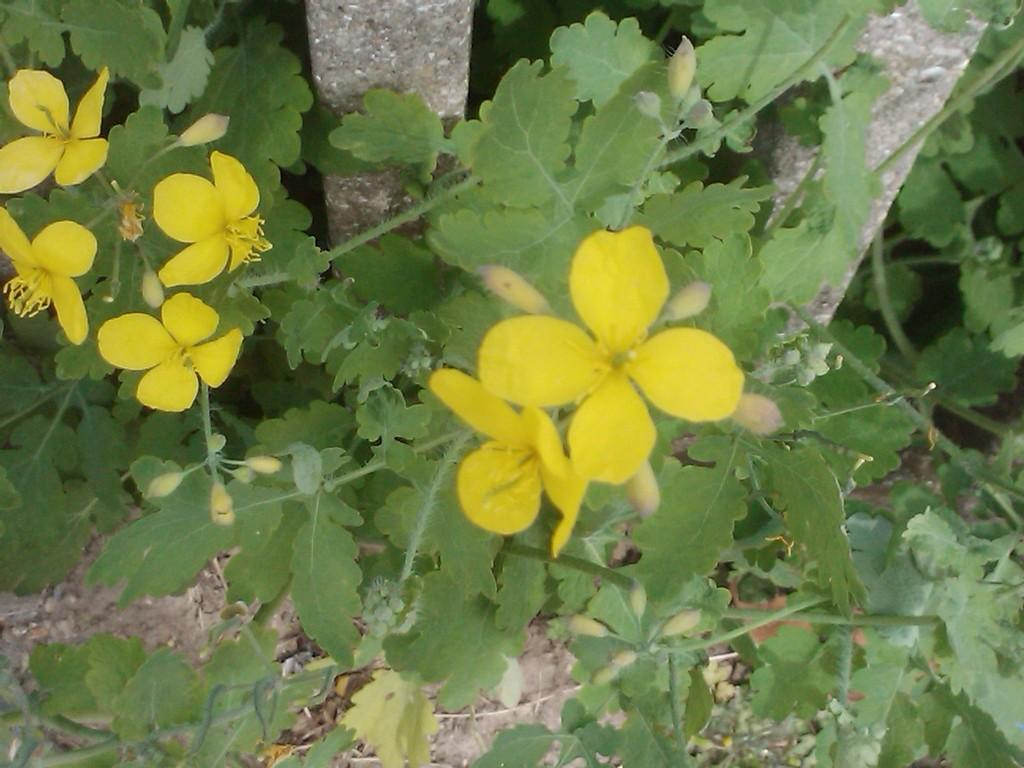What type of flora can be seen in the image? There are flowers and plants visible in the image. Where are the plants located in the image? The plants are on the ground in the image. What can be seen in the background of the image? There are tree trunks visible in the background of the image. How many boys are playing in the scene depicted in the image? There are no boys present in the image; it features flowers, plants, and tree trunks. 